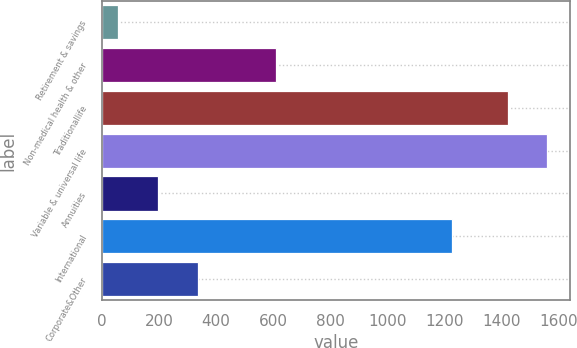Convert chart. <chart><loc_0><loc_0><loc_500><loc_500><bar_chart><fcel>Retirement & savings<fcel>Non-medical health & other<fcel>Traditionallife<fcel>Variable & universal life<fcel>Annuities<fcel>International<fcel>Corporate&Other<nl><fcel>58<fcel>609<fcel>1423<fcel>1562.4<fcel>197.4<fcel>1227<fcel>336.8<nl></chart> 